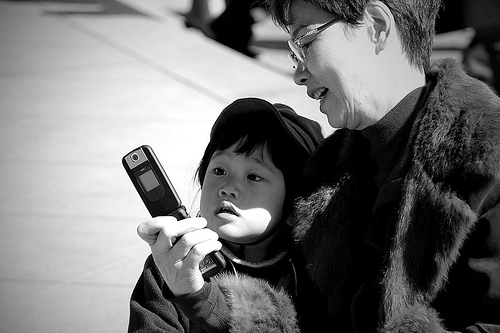Can you describe the expressions on their faces? Both individuals have a look of concentration, with the child's gaze particularly focused on the screen, while the adult seems to be explaining or showing something to the child. 